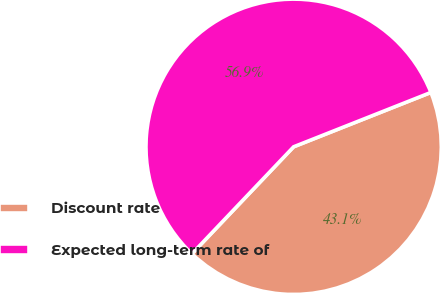Convert chart. <chart><loc_0><loc_0><loc_500><loc_500><pie_chart><fcel>Discount rate<fcel>Expected long-term rate of<nl><fcel>43.1%<fcel>56.9%<nl></chart> 